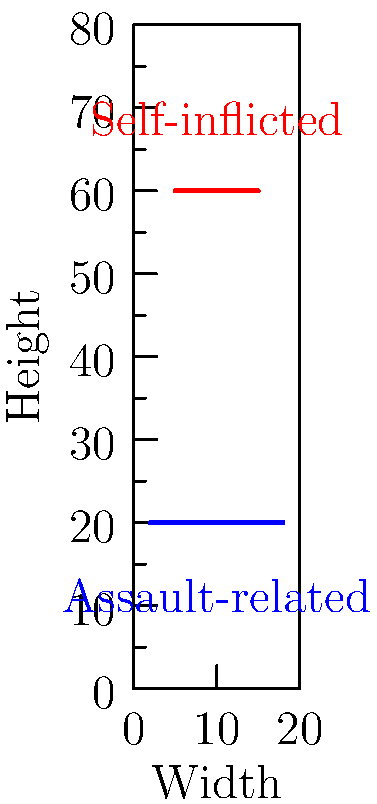In a case involving alleged domestic violence, you're presented with a body mapping diagram showing injury patterns. Based on the diagram, which characteristic is more likely to indicate a self-inflicted injury as opposed to an assault-related injury? To differentiate between self-inflicted and assault-related injuries using body mapping diagrams, consider the following steps:

1. Examine the location of injuries:
   - Self-inflicted injuries are often in easily accessible areas.
   - Assault-related injuries may be in less accessible areas.

2. Analyze the pattern of injuries:
   - Self-inflicted injuries tend to be more uniform and parallel.
   - Assault-related injuries are often more scattered and varied.

3. Consider the length and direction of injuries:
   - Self-inflicted injuries are typically shorter and more controlled.
   - Assault-related injuries may be longer and show less control.

4. Look for defensive wounds:
   - Self-inflicted injuries rarely include defensive wounds.
   - Assault-related injuries often include defensive wounds on hands or arms.

5. Assess the depth and severity:
   - Self-inflicted injuries may have a more consistent depth.
   - Assault-related injuries can vary significantly in depth and severity.

In the diagram:
- The red line represents a self-inflicted injury: shorter, more controlled, and in an easily accessible area.
- The blue line represents an assault-related injury: longer, less controlled, and in a less accessible area.

Therefore, the characteristic more likely to indicate a self-inflicted injury is the shorter, more uniform pattern in an easily accessible area.
Answer: Shorter, uniform pattern in an easily accessible area 